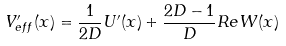<formula> <loc_0><loc_0><loc_500><loc_500>V ^ { \prime } _ { e f f } ( x ) = \frac { 1 } { 2 D } U ^ { \prime } ( x ) + \frac { 2 D - 1 } { D } R e W ( x )</formula> 